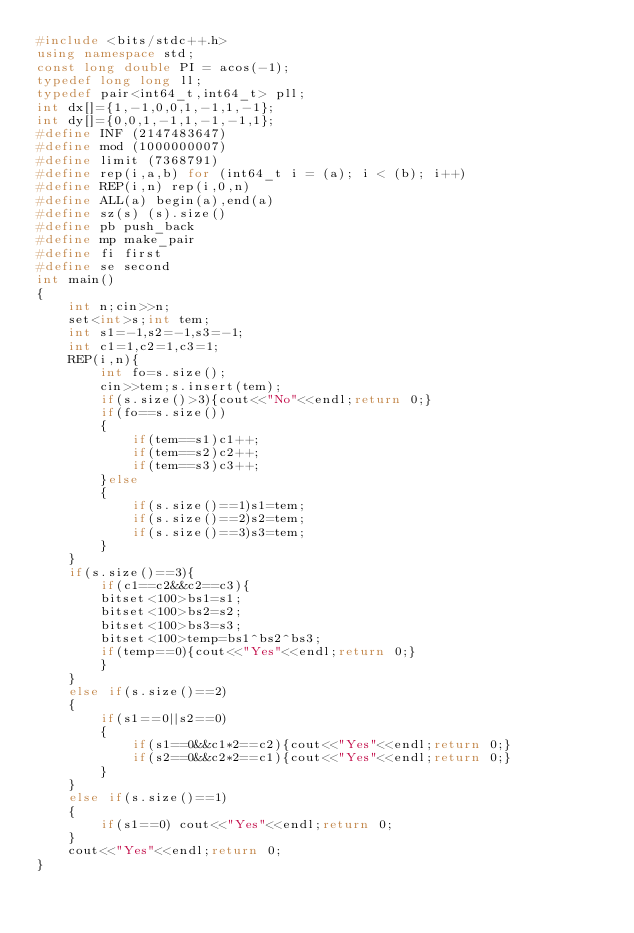Convert code to text. <code><loc_0><loc_0><loc_500><loc_500><_C++_>#include <bits/stdc++.h>
using namespace std;
const long double PI = acos(-1);
typedef long long ll;
typedef pair<int64_t,int64_t> pll;
int dx[]={1,-1,0,0,1,-1,1,-1};
int dy[]={0,0,1,-1,1,-1,-1,1};
#define INF (2147483647)
#define mod (1000000007)
#define limit (7368791)
#define rep(i,a,b) for (int64_t i = (a); i < (b); i++)
#define REP(i,n) rep(i,0,n)
#define ALL(a) begin(a),end(a)
#define sz(s) (s).size()
#define pb push_back
#define mp make_pair
#define fi first
#define se second
int main()
{
    int n;cin>>n;
    set<int>s;int tem;
    int s1=-1,s2=-1,s3=-1;
    int c1=1,c2=1,c3=1;
    REP(i,n){
        int fo=s.size();
        cin>>tem;s.insert(tem);
        if(s.size()>3){cout<<"No"<<endl;return 0;}
        if(fo==s.size())
        {   
            if(tem==s1)c1++;
            if(tem==s2)c2++;
            if(tem==s3)c3++;
        }else
        {
            if(s.size()==1)s1=tem;
            if(s.size()==2)s2=tem;
            if(s.size()==3)s3=tem;
        }
    }
    if(s.size()==3){
        if(c1==c2&&c2==c3){
        bitset<100>bs1=s1;
        bitset<100>bs2=s2;
        bitset<100>bs3=s3;
        bitset<100>temp=bs1^bs2^bs3;
        if(temp==0){cout<<"Yes"<<endl;return 0;}
        }
    }
    else if(s.size()==2)
    {
        if(s1==0||s2==0)
        {
            if(s1==0&&c1*2==c2){cout<<"Yes"<<endl;return 0;}
            if(s2==0&&c2*2==c1){cout<<"Yes"<<endl;return 0;}
        }
    }
    else if(s.size()==1)
    {
        if(s1==0) cout<<"Yes"<<endl;return 0;
    }
    cout<<"Yes"<<endl;return 0;
}</code> 